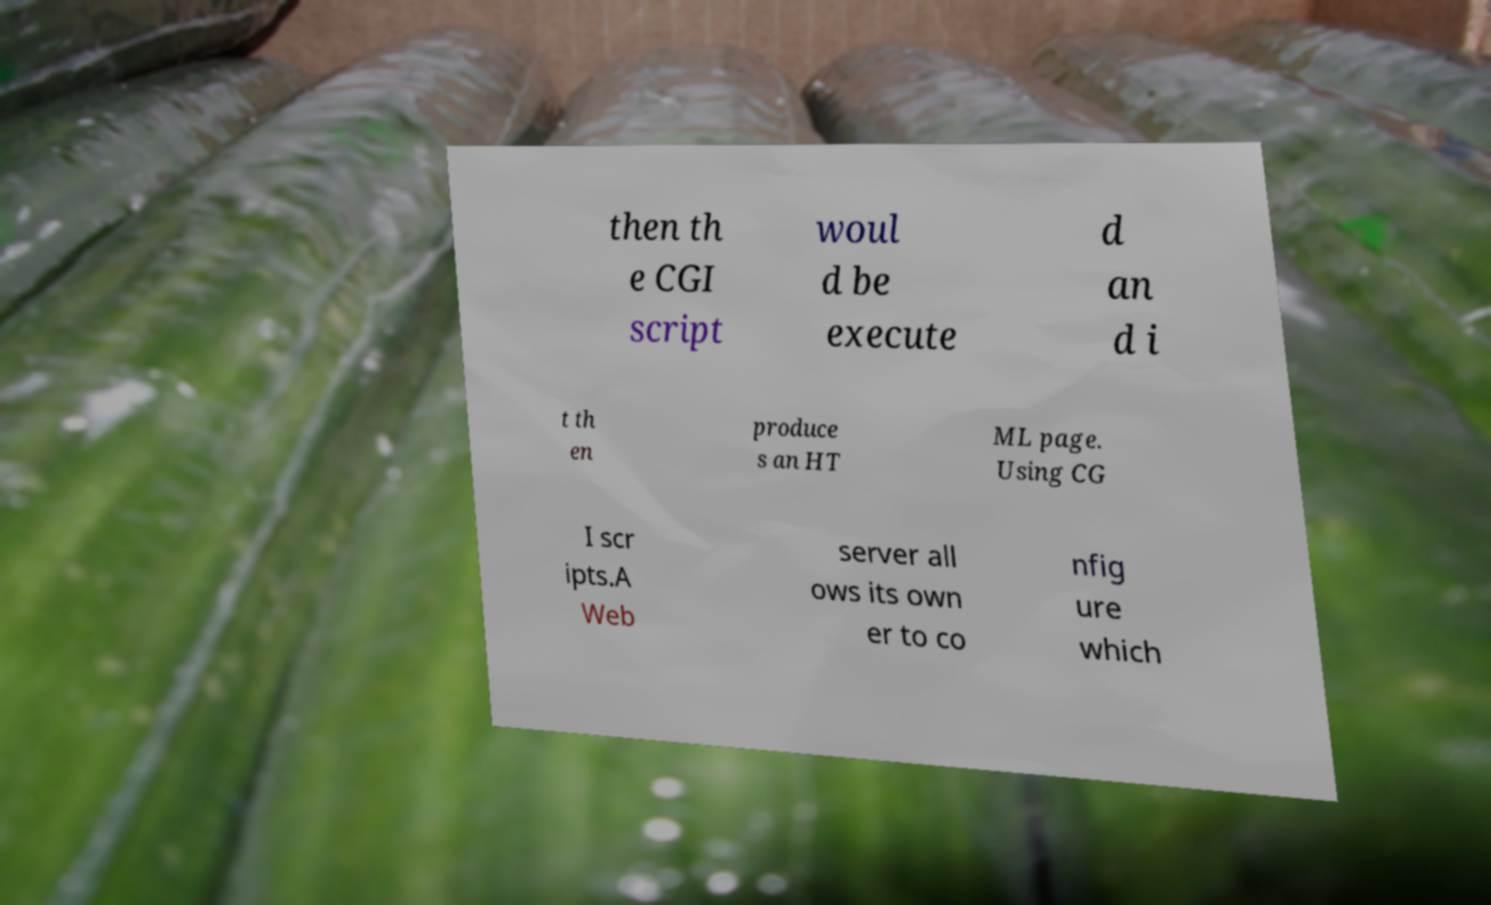Can you read and provide the text displayed in the image?This photo seems to have some interesting text. Can you extract and type it out for me? then th e CGI script woul d be execute d an d i t th en produce s an HT ML page. Using CG I scr ipts.A Web server all ows its own er to co nfig ure which 